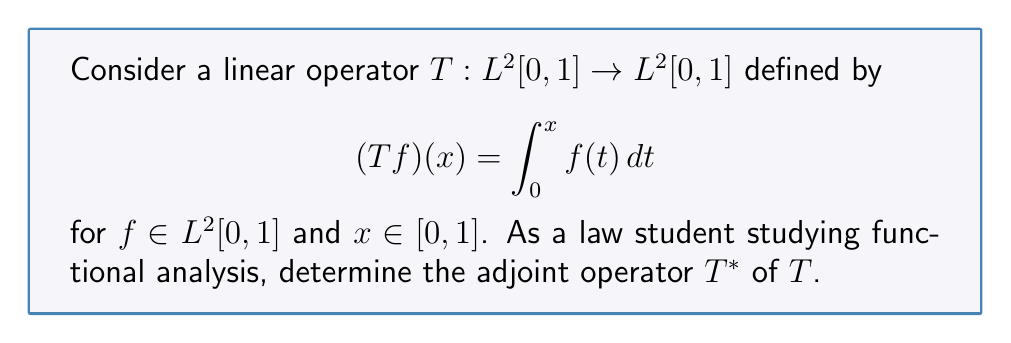What is the answer to this math problem? To find the adjoint operator $T^*$, we need to follow these steps:

1) Recall the definition of an adjoint operator: For all $f, g \in L^2[0,1]$, 
   $$\langle Tf, g \rangle = \langle f, T^*g \rangle$$

2) Let's start with the left side of this equation:
   $$\langle Tf, g \rangle = \int_0^1 (Tf)(x)g(x)dx = \int_0^1 \left(\int_0^x f(t)dt\right)g(x)dx$$

3) We can change the order of integration using Fubini's theorem:
   $$\int_0^1 \left(\int_0^x f(t)dt\right)g(x)dx = \int_0^1 \int_t^1 f(t)g(x)dx dt$$

4) Now, let's focus on the right side of the equation in step 1:
   $$\langle f, T^*g \rangle = \int_0^1 f(t)(T^*g)(t)dt$$

5) Comparing this with the result from step 3, we can deduce that:
   $$(T^*g)(t) = \int_t^1 g(x)dx$$

6) Therefore, the adjoint operator $T^*$ is defined as:
   $$(T^*g)(t) = \int_t^1 g(x)dx$$
   for $g \in L^2[0,1]$ and $t \in [0,1]$.

This operator $T^*$ satisfies the definition of the adjoint operator for all $f, g \in L^2[0,1]$.
Answer: $(T^*g)(t) = \int_t^1 g(x)dx$ 